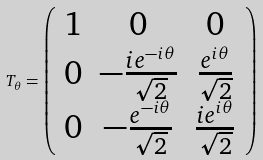<formula> <loc_0><loc_0><loc_500><loc_500>T _ { \theta } = \left ( \begin{array} { c c c } 1 & 0 & 0 \\ 0 & - \frac { i e ^ { - i \theta } } { \sqrt { 2 } } & \frac { e ^ { i \theta } } { \sqrt { 2 } } \\ 0 & - \frac { e ^ { - i \theta } } { \sqrt { 2 } } & \frac { i e ^ { i \theta } } { \sqrt { 2 } } \\ \end{array} \right )</formula> 